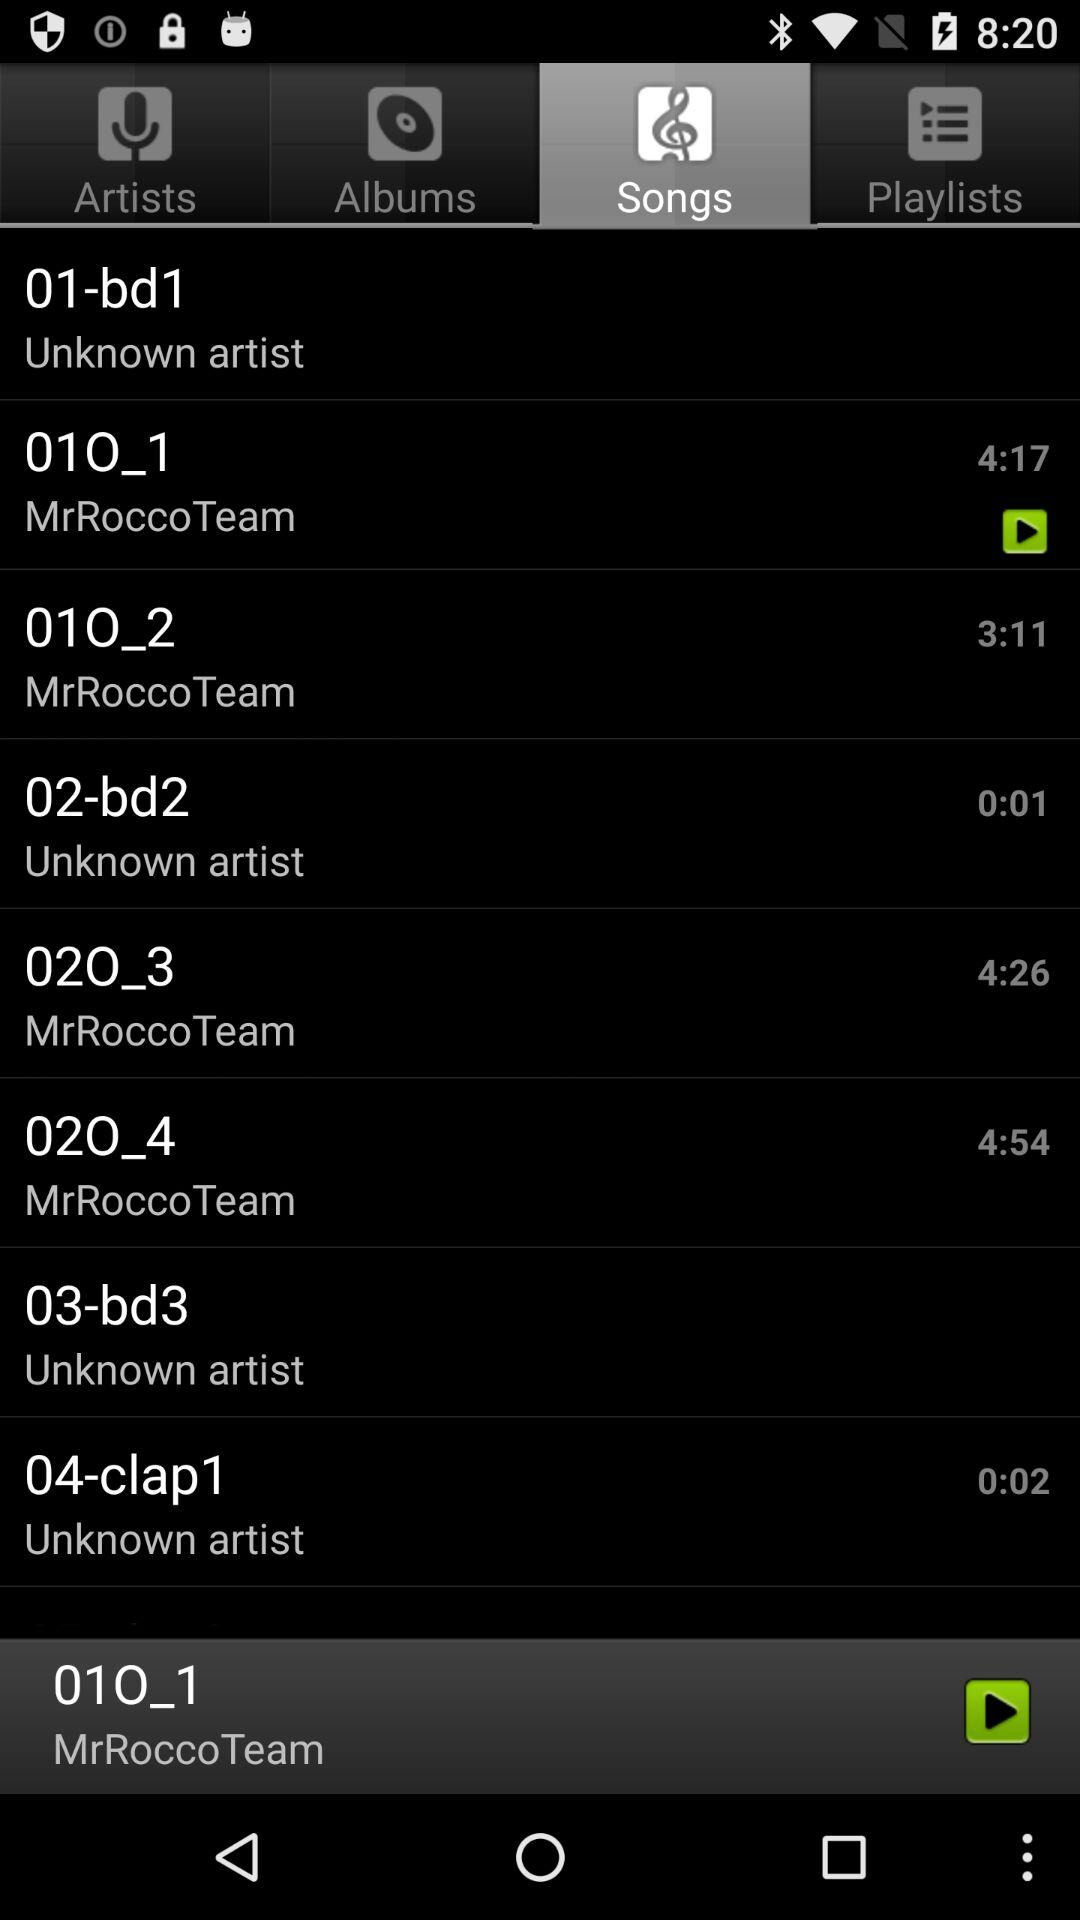What is the time duration for "020_3" song? The time duration for "020_3" song is 4 minutes 54 seconds. 